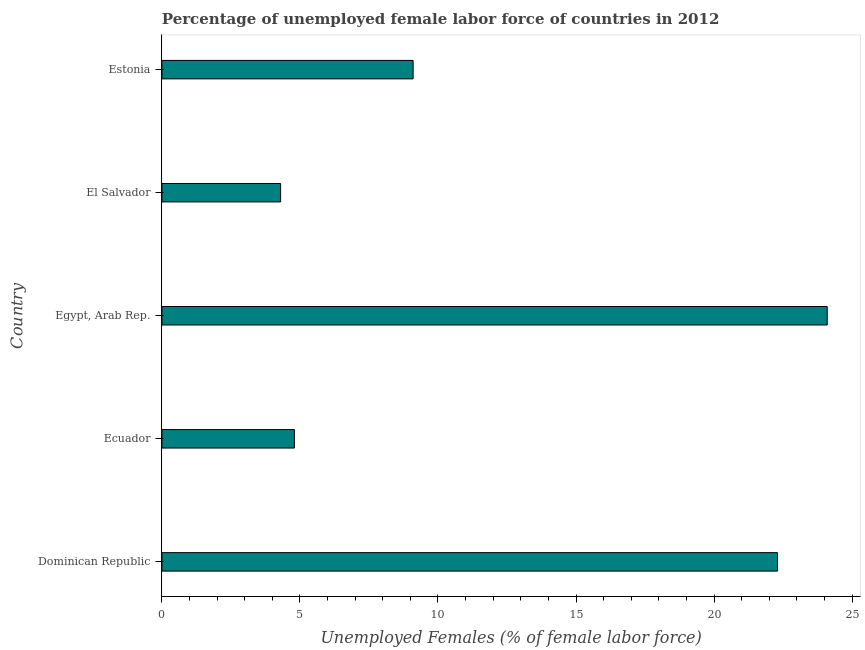Does the graph contain any zero values?
Your answer should be very brief. No. Does the graph contain grids?
Your answer should be very brief. No. What is the title of the graph?
Ensure brevity in your answer.  Percentage of unemployed female labor force of countries in 2012. What is the label or title of the X-axis?
Your answer should be compact. Unemployed Females (% of female labor force). What is the total unemployed female labour force in Estonia?
Provide a short and direct response. 9.1. Across all countries, what is the maximum total unemployed female labour force?
Provide a short and direct response. 24.1. Across all countries, what is the minimum total unemployed female labour force?
Your response must be concise. 4.3. In which country was the total unemployed female labour force maximum?
Your response must be concise. Egypt, Arab Rep. In which country was the total unemployed female labour force minimum?
Keep it short and to the point. El Salvador. What is the sum of the total unemployed female labour force?
Your answer should be very brief. 64.6. What is the difference between the total unemployed female labour force in Ecuador and Egypt, Arab Rep.?
Your answer should be very brief. -19.3. What is the average total unemployed female labour force per country?
Ensure brevity in your answer.  12.92. What is the median total unemployed female labour force?
Provide a short and direct response. 9.1. What is the ratio of the total unemployed female labour force in El Salvador to that in Estonia?
Provide a short and direct response. 0.47. What is the difference between the highest and the lowest total unemployed female labour force?
Provide a short and direct response. 19.8. How many bars are there?
Make the answer very short. 5. What is the Unemployed Females (% of female labor force) of Dominican Republic?
Keep it short and to the point. 22.3. What is the Unemployed Females (% of female labor force) of Ecuador?
Your answer should be compact. 4.8. What is the Unemployed Females (% of female labor force) in Egypt, Arab Rep.?
Make the answer very short. 24.1. What is the Unemployed Females (% of female labor force) in El Salvador?
Your response must be concise. 4.3. What is the Unemployed Females (% of female labor force) in Estonia?
Offer a terse response. 9.1. What is the difference between the Unemployed Females (% of female labor force) in Dominican Republic and Ecuador?
Provide a short and direct response. 17.5. What is the difference between the Unemployed Females (% of female labor force) in Ecuador and Egypt, Arab Rep.?
Your answer should be compact. -19.3. What is the difference between the Unemployed Females (% of female labor force) in Ecuador and Estonia?
Make the answer very short. -4.3. What is the difference between the Unemployed Females (% of female labor force) in Egypt, Arab Rep. and El Salvador?
Keep it short and to the point. 19.8. What is the difference between the Unemployed Females (% of female labor force) in El Salvador and Estonia?
Your answer should be very brief. -4.8. What is the ratio of the Unemployed Females (% of female labor force) in Dominican Republic to that in Ecuador?
Provide a short and direct response. 4.65. What is the ratio of the Unemployed Females (% of female labor force) in Dominican Republic to that in Egypt, Arab Rep.?
Provide a short and direct response. 0.93. What is the ratio of the Unemployed Females (% of female labor force) in Dominican Republic to that in El Salvador?
Offer a very short reply. 5.19. What is the ratio of the Unemployed Females (% of female labor force) in Dominican Republic to that in Estonia?
Your answer should be compact. 2.45. What is the ratio of the Unemployed Females (% of female labor force) in Ecuador to that in Egypt, Arab Rep.?
Ensure brevity in your answer.  0.2. What is the ratio of the Unemployed Females (% of female labor force) in Ecuador to that in El Salvador?
Give a very brief answer. 1.12. What is the ratio of the Unemployed Females (% of female labor force) in Ecuador to that in Estonia?
Your answer should be compact. 0.53. What is the ratio of the Unemployed Females (% of female labor force) in Egypt, Arab Rep. to that in El Salvador?
Provide a short and direct response. 5.61. What is the ratio of the Unemployed Females (% of female labor force) in Egypt, Arab Rep. to that in Estonia?
Provide a short and direct response. 2.65. What is the ratio of the Unemployed Females (% of female labor force) in El Salvador to that in Estonia?
Your response must be concise. 0.47. 